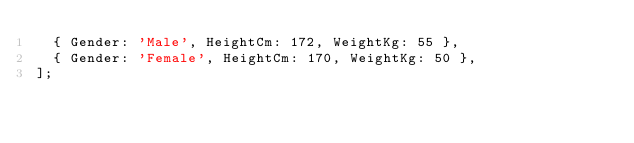Convert code to text. <code><loc_0><loc_0><loc_500><loc_500><_TypeScript_>  { Gender: 'Male', HeightCm: 172, WeightKg: 55 },
  { Gender: 'Female', HeightCm: 170, WeightKg: 50 },
];


</code> 